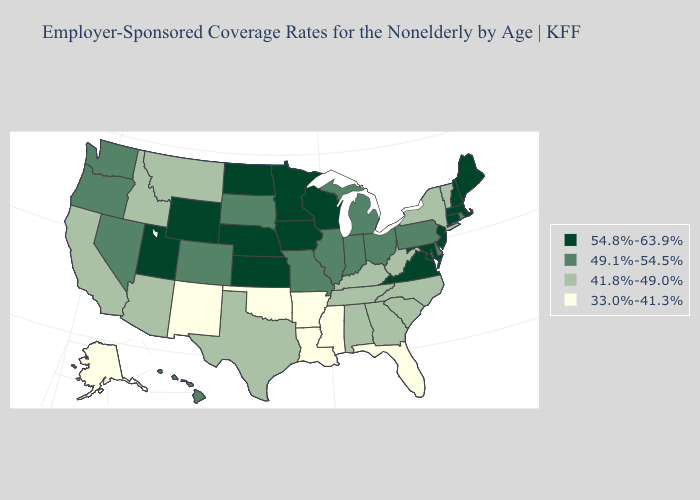What is the lowest value in the USA?
Give a very brief answer. 33.0%-41.3%. Does Wisconsin have the lowest value in the MidWest?
Answer briefly. No. Name the states that have a value in the range 49.1%-54.5%?
Quick response, please. Colorado, Delaware, Hawaii, Illinois, Indiana, Michigan, Missouri, Nevada, Ohio, Oregon, Pennsylvania, Rhode Island, South Dakota, Washington. Among the states that border Oregon , does California have the highest value?
Be succinct. No. Does Illinois have a lower value than New Hampshire?
Write a very short answer. Yes. What is the lowest value in the USA?
Quick response, please. 33.0%-41.3%. Does the map have missing data?
Write a very short answer. No. What is the value of Kentucky?
Write a very short answer. 41.8%-49.0%. What is the value of North Dakota?
Give a very brief answer. 54.8%-63.9%. What is the lowest value in states that border Minnesota?
Keep it brief. 49.1%-54.5%. Name the states that have a value in the range 54.8%-63.9%?
Be succinct. Connecticut, Iowa, Kansas, Maine, Maryland, Massachusetts, Minnesota, Nebraska, New Hampshire, New Jersey, North Dakota, Utah, Virginia, Wisconsin, Wyoming. Name the states that have a value in the range 54.8%-63.9%?
Keep it brief. Connecticut, Iowa, Kansas, Maine, Maryland, Massachusetts, Minnesota, Nebraska, New Hampshire, New Jersey, North Dakota, Utah, Virginia, Wisconsin, Wyoming. Name the states that have a value in the range 41.8%-49.0%?
Answer briefly. Alabama, Arizona, California, Georgia, Idaho, Kentucky, Montana, New York, North Carolina, South Carolina, Tennessee, Texas, Vermont, West Virginia. How many symbols are there in the legend?
Write a very short answer. 4. Name the states that have a value in the range 49.1%-54.5%?
Give a very brief answer. Colorado, Delaware, Hawaii, Illinois, Indiana, Michigan, Missouri, Nevada, Ohio, Oregon, Pennsylvania, Rhode Island, South Dakota, Washington. 